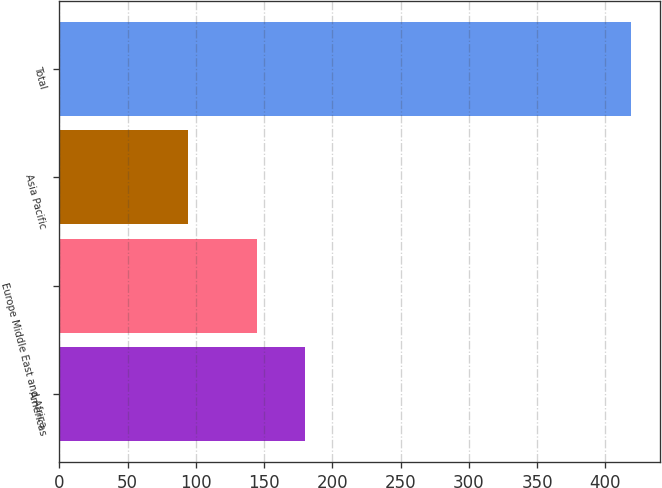Convert chart to OTSL. <chart><loc_0><loc_0><loc_500><loc_500><bar_chart><fcel>Americas<fcel>Europe Middle East and Africa<fcel>Asia Pacific<fcel>Total<nl><fcel>180<fcel>145<fcel>94<fcel>419<nl></chart> 